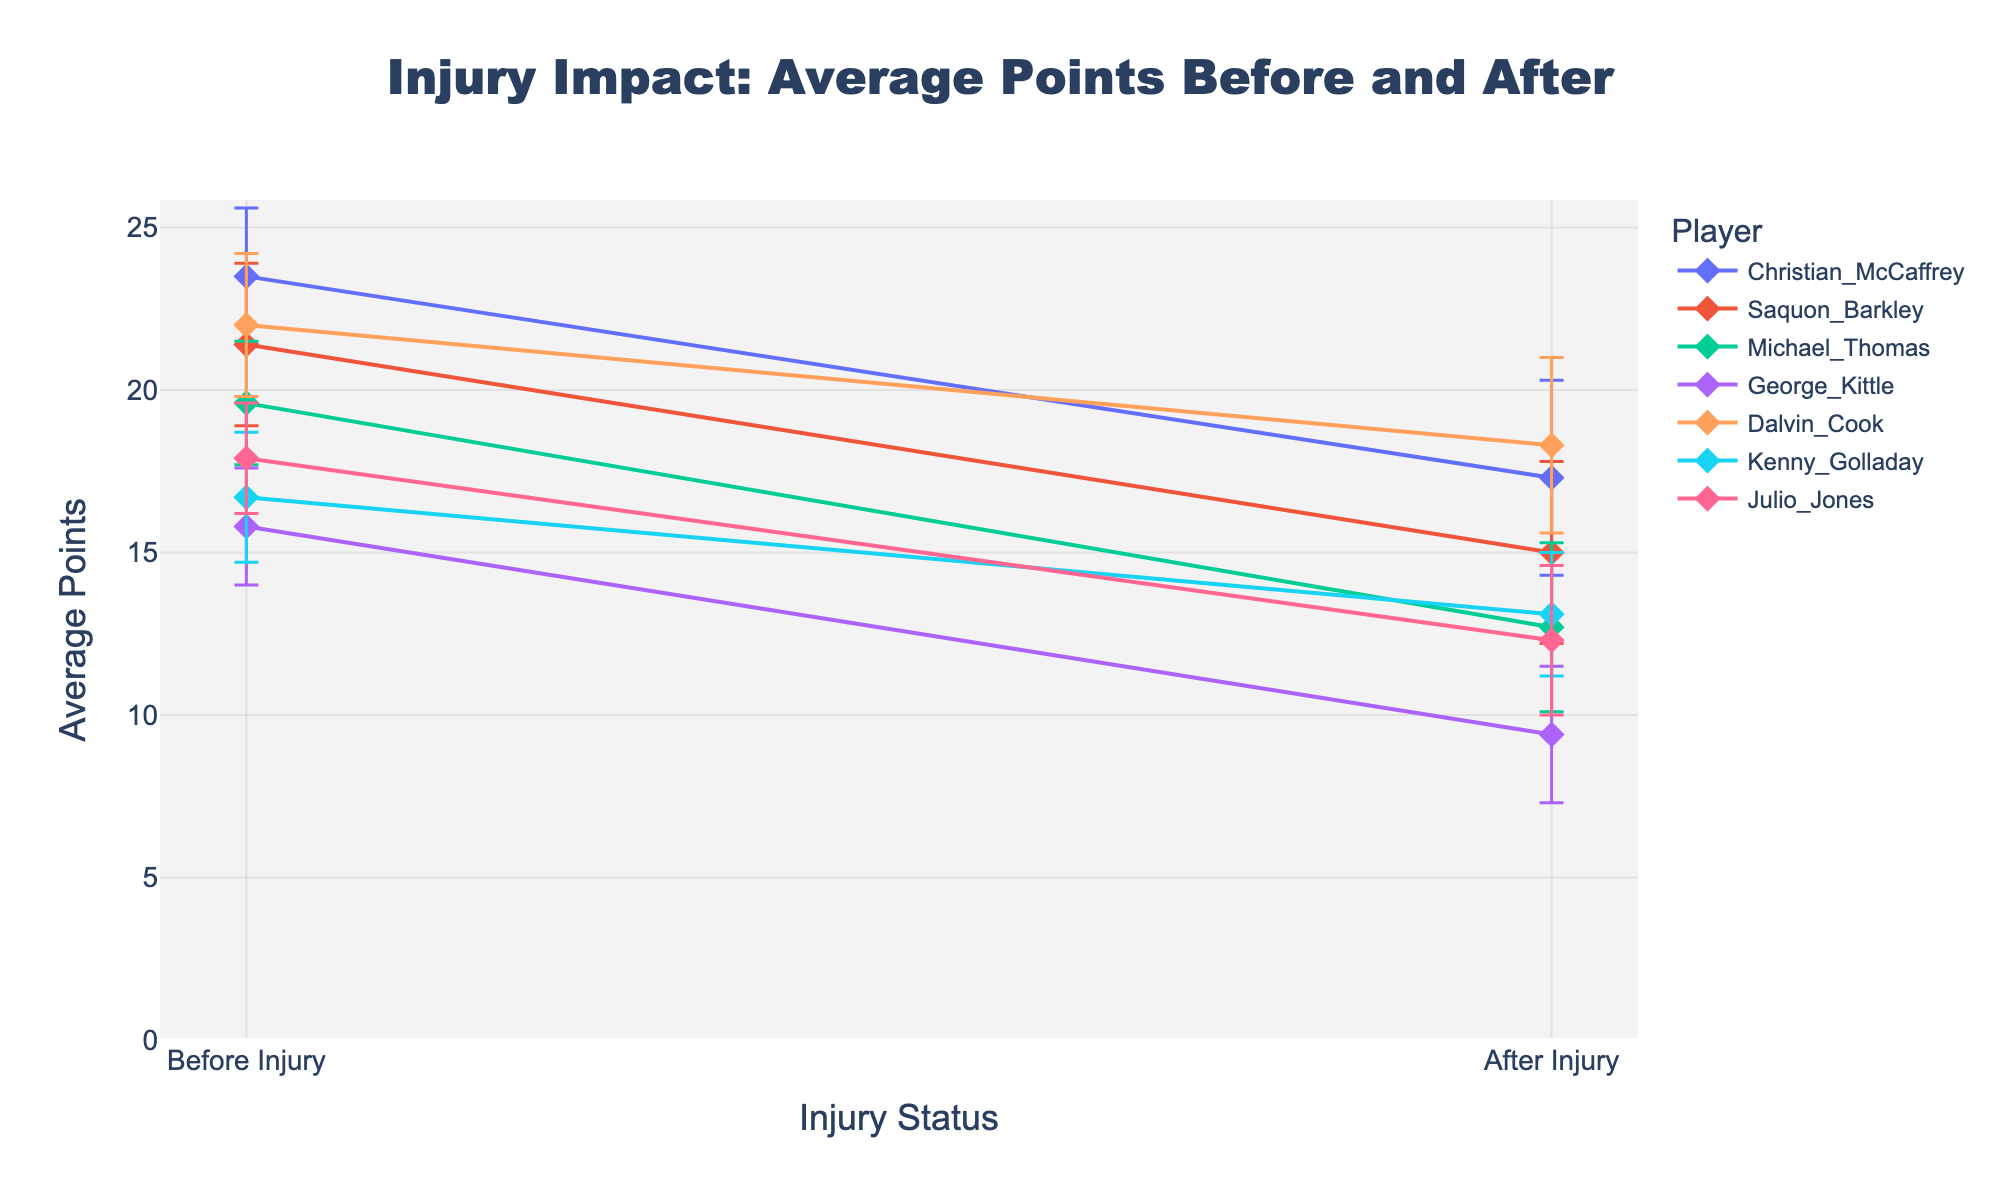What's the title of the figure? The title of the figure is displayed prominently at the top of the plot. It provides an overview of what the plot is depicting.
Answer: Injury Impact: Average Points Before and After What does the x-axis represent? The x-axis represents the different injury statuses of the players, specifically "Before Injury" and "After Injury".
Answer: Injury statuses What is the y-axis range for the average points? The y-axis range is determined by the highest average points shown in the plot, allowing about 10% more of the maximum value to ensure all points and error bars are visible. The highest average points go up to around 23.5, so the maximum range should be slightly above this value.
Answer: 0 to around 26 Which player had the highest average points before their injury? Look at the topmost point on the graph in the 'Before Injury' category and identify the player's label.
Answer: Christian McCaffrey Which player shows the greatest decrease in average points due to their injury? Determine the difference between the 'AvgPointsBefore' and 'AvgPointsAfter' for each player and identify the player with the largest drop. Christian McCaffrey's points drop from 23.5 to 17.3, Saquon Barkley from 21.4 to 15.0, Michael Thomas from 19.6 to 12.7, George Kittle from 15.8 to 9.4, Dalvin Cook from 22.0 to 18.3, Kenny Golladay from 16.7 to 13.1, and Julio Jones from 17.9 to 12.3. The largest drop is for Michael Thomas.
Answer: Michael Thomas Which player has the smallest error margin after injury? Look at the error bars associated with the average points after injury and identify the player with the shortest error bar.
Answer: Kenny Golladay Between "Before Injury" and "After Injury", which situation generally shows a larger average points with higher error margins? Overall changes in average points and their respective error margins need to be considered. In the ‘Before Injury’ situation, most average points values are higher, and error margins are generally large compared to the 'After Injury'.
Answer: Before Injury Which player's performance is least affected by injury, considering both average points and error margins? Look at both the decrease in average points and the size of the error margins. Dalvin Cook's average points decreased the least from 22.0 to 18.3, with error margins remaining fairly consistent.
Answer: Dalvin Cook 